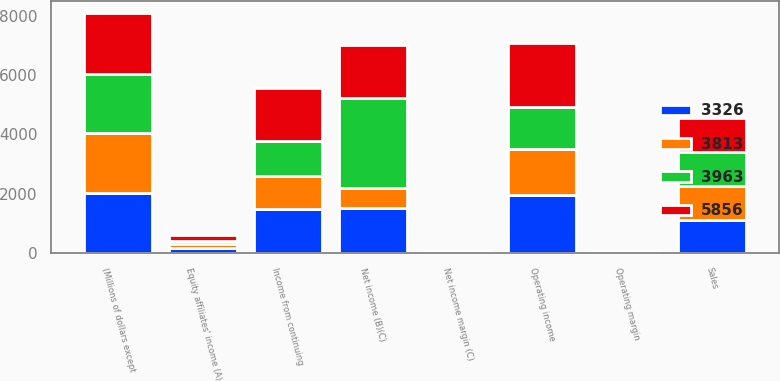Convert chart. <chart><loc_0><loc_0><loc_500><loc_500><stacked_bar_chart><ecel><fcel>(Millions of dollars except<fcel>Sales<fcel>Operating income<fcel>Operating margin<fcel>Equity affiliates' income (A)<fcel>Net income (B)(C)<fcel>Net income margin (C)<fcel>Income from continuing<nl><fcel>5856<fcel>2019<fcel>1138.5<fcel>2144<fcel>24<fcel>215<fcel>1809<fcel>20.3<fcel>1809<nl><fcel>3326<fcel>2018<fcel>1138.5<fcel>1966<fcel>22<fcel>175<fcel>1533<fcel>17.2<fcel>1491<nl><fcel>3963<fcel>2017<fcel>1138.5<fcel>1440<fcel>17.6<fcel>80<fcel>3021<fcel>36.9<fcel>1155<nl><fcel>3813<fcel>2016<fcel>1138.5<fcel>1535<fcel>20.5<fcel>147<fcel>662<fcel>8.8<fcel>1122<nl></chart> 